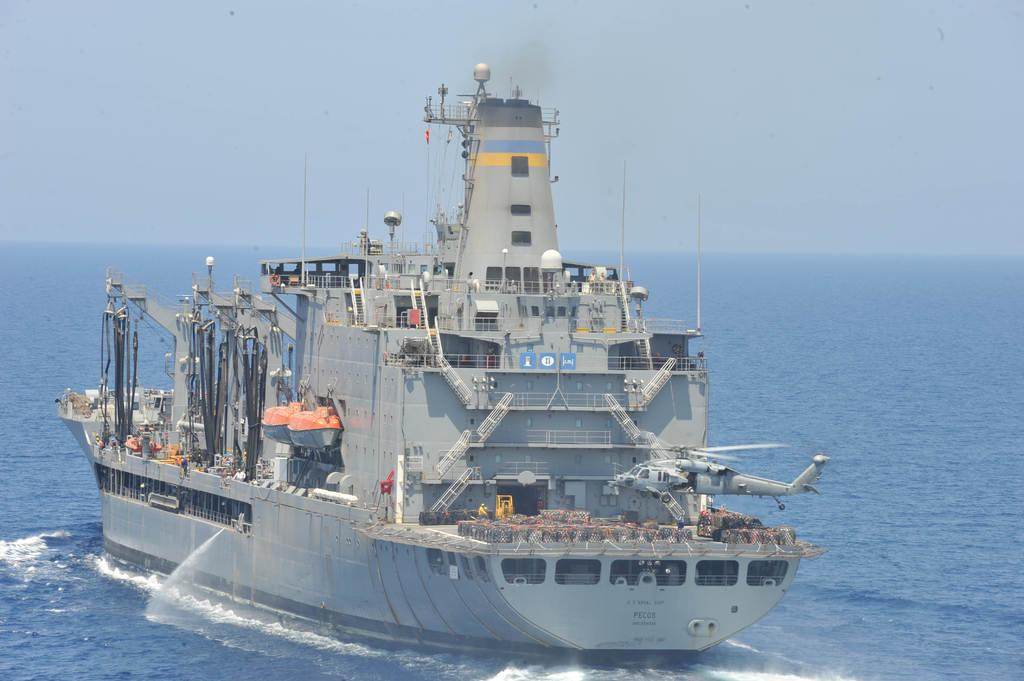What is flying in the image? There is a helicopter flying in the image. What is located on the water in the image? There is a ship on the water in the image. What can be seen in the background of the image? The sky is visible in the background of the image. What letter does the grandfather write to the helicopter pilot in the image? There is no grandfather or letter present in the image. 